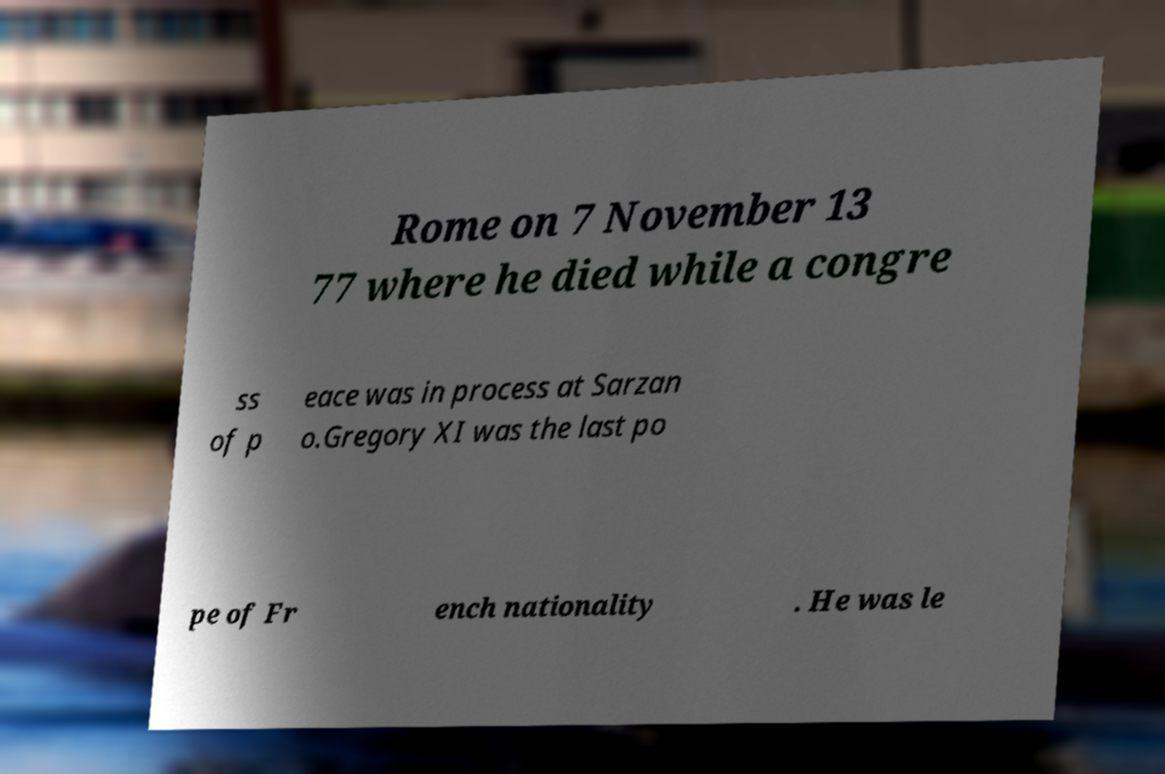What messages or text are displayed in this image? I need them in a readable, typed format. The image displays a paper with partial text reading: 'Rome on 7 November 1377 where he died while a congress of peace was in process at Sarzan. Gregory XI was the last pope of French nationality. He was le'. The text appears to be cut off and incomplete. 